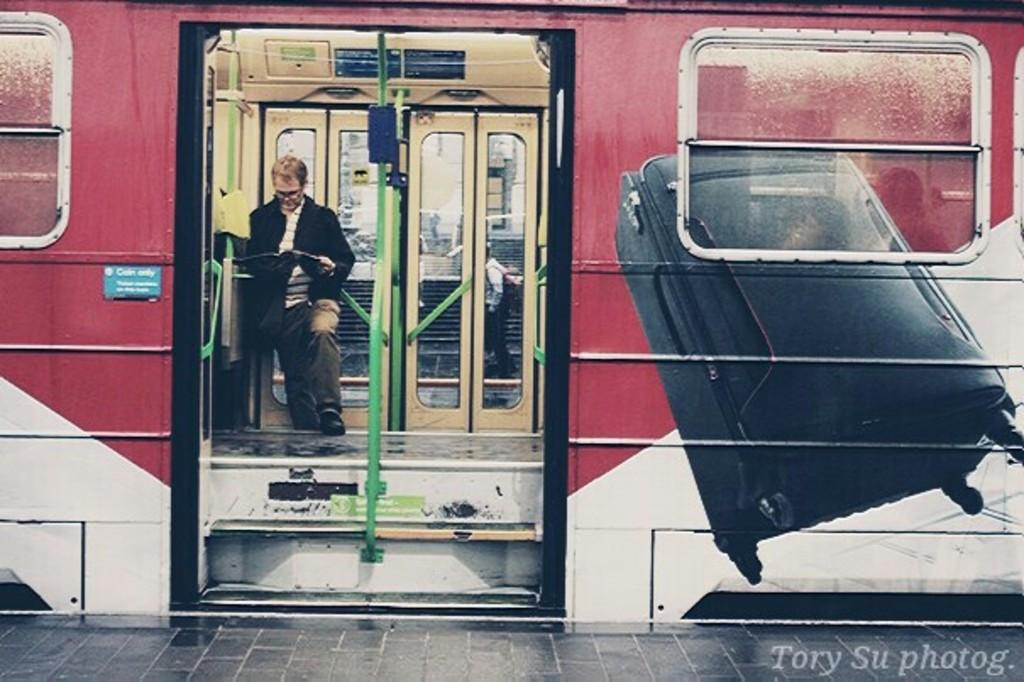What is the main subject of the image? There is a train in the image. Can you describe the person inside the train? A person is standing inside the train, and they are holding a book. What is visible in front of the train? There is a platform in front of the train. How many horses are visible on the platform in the image? There are no horses present in the image; it features a train with a person holding a book inside and a platform in front. What type of underwear is the person wearing in the image? There is no information about the person's underwear in the image, as it is not visible or mentioned in the provided facts. 